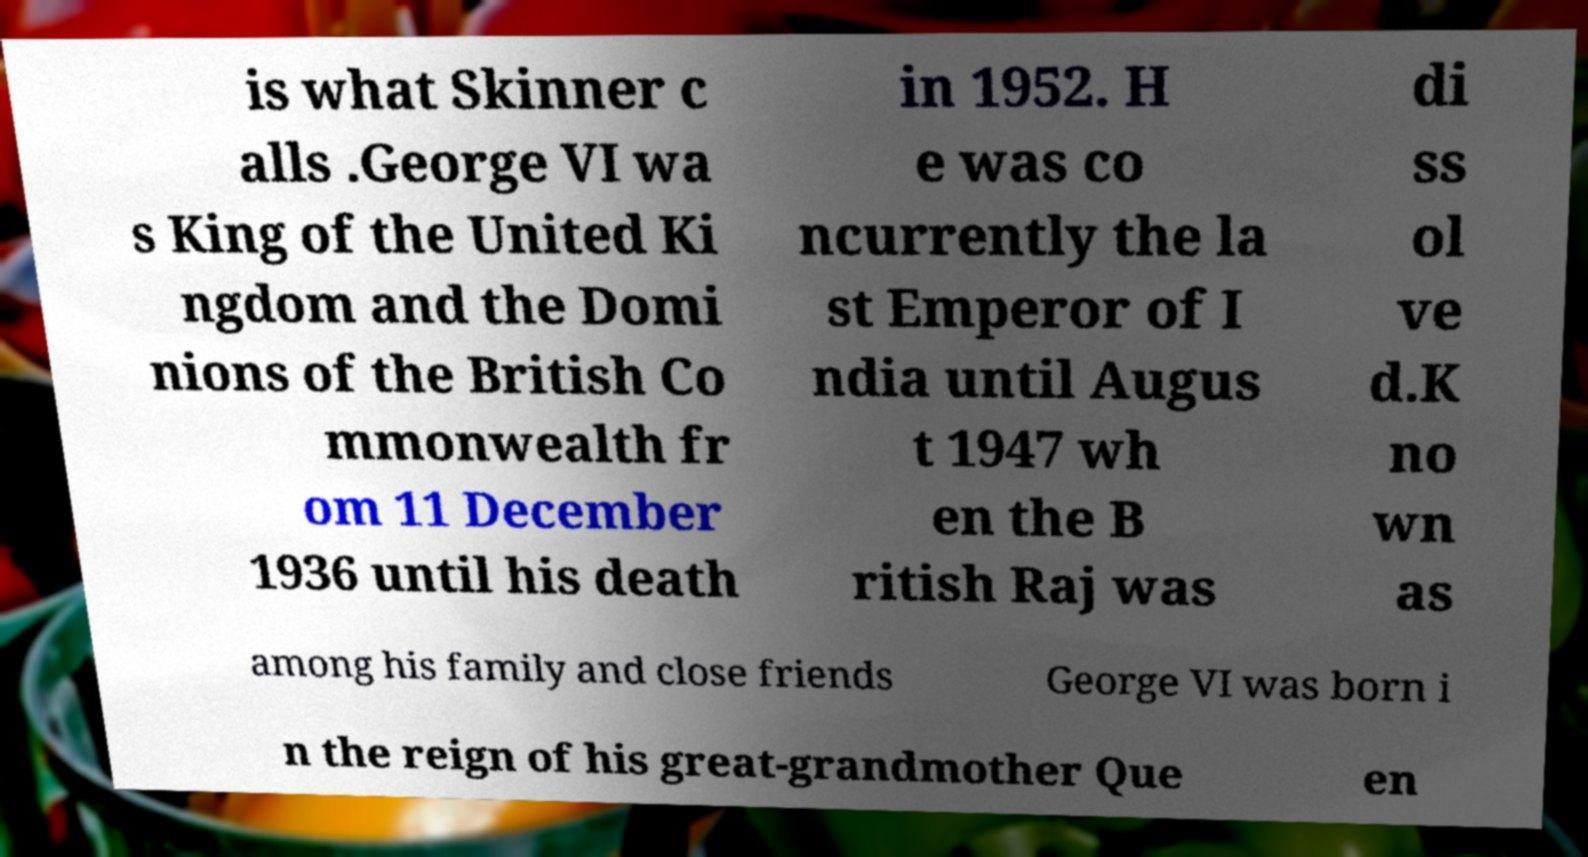There's text embedded in this image that I need extracted. Can you transcribe it verbatim? is what Skinner c alls .George VI wa s King of the United Ki ngdom and the Domi nions of the British Co mmonwealth fr om 11 December 1936 until his death in 1952. H e was co ncurrently the la st Emperor of I ndia until Augus t 1947 wh en the B ritish Raj was di ss ol ve d.K no wn as among his family and close friends George VI was born i n the reign of his great-grandmother Que en 